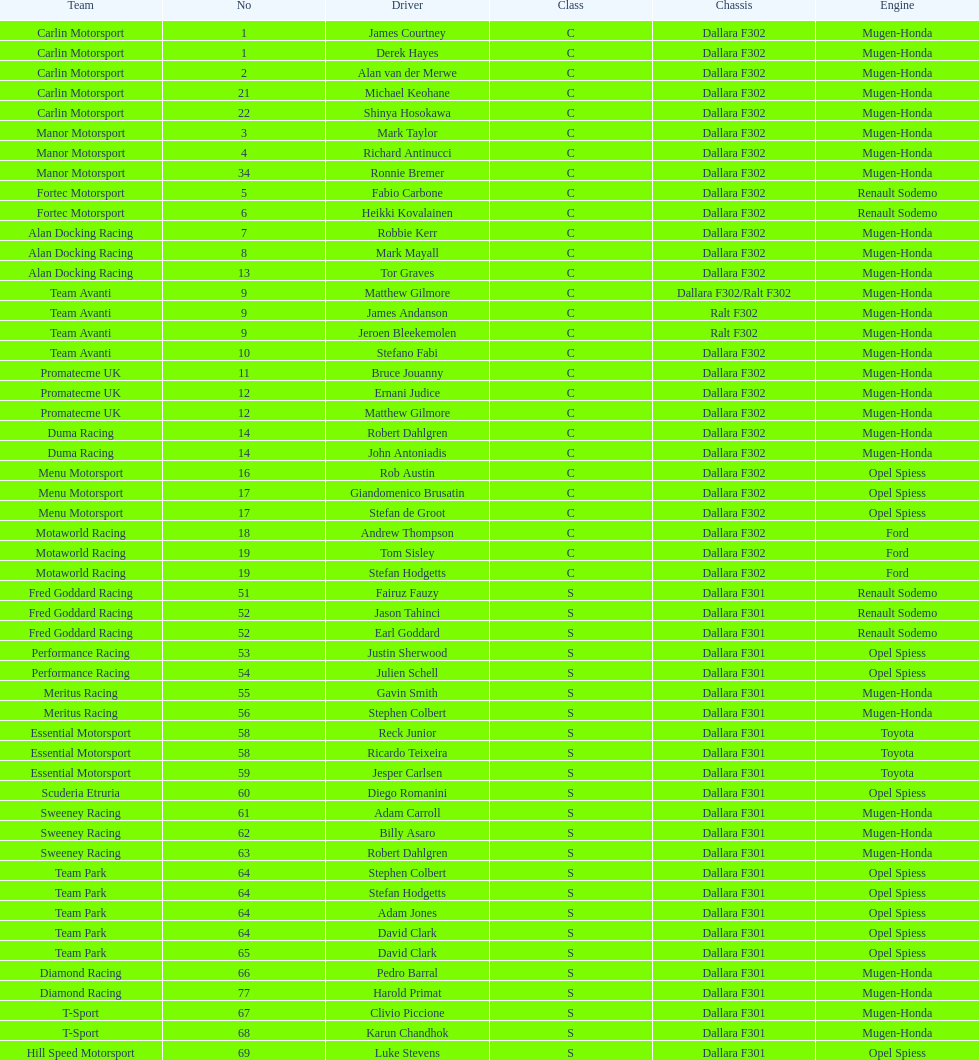What is the mean count of teams that possessed a mugen-honda engine? 24. 